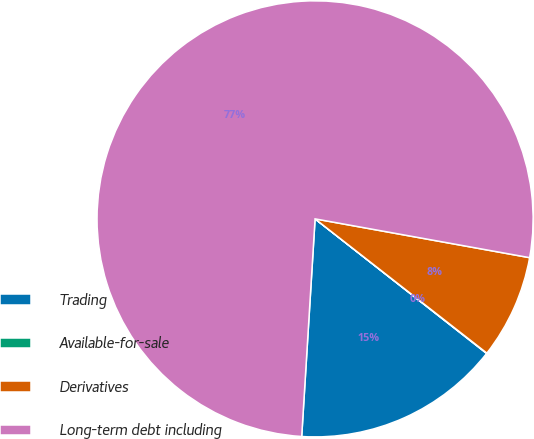<chart> <loc_0><loc_0><loc_500><loc_500><pie_chart><fcel>Trading<fcel>Available-for-sale<fcel>Derivatives<fcel>Long-term debt including<nl><fcel>15.39%<fcel>0.03%<fcel>7.71%<fcel>76.87%<nl></chart> 